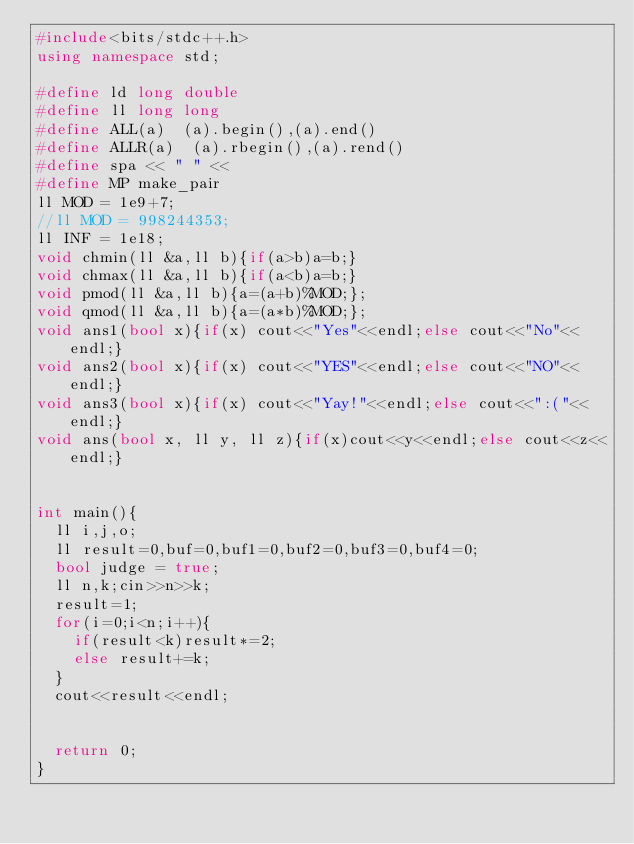<code> <loc_0><loc_0><loc_500><loc_500><_C++_>#include<bits/stdc++.h>
using namespace std;

#define ld long double
#define ll long long
#define ALL(a)  (a).begin(),(a).end()
#define ALLR(a)  (a).rbegin(),(a).rend()
#define spa << " " <<
#define MP make_pair
ll MOD = 1e9+7;
//ll MOD = 998244353;
ll INF = 1e18;
void chmin(ll &a,ll b){if(a>b)a=b;}
void chmax(ll &a,ll b){if(a<b)a=b;}
void pmod(ll &a,ll b){a=(a+b)%MOD;};
void qmod(ll &a,ll b){a=(a*b)%MOD;};
void ans1(bool x){if(x) cout<<"Yes"<<endl;else cout<<"No"<<endl;}
void ans2(bool x){if(x) cout<<"YES"<<endl;else cout<<"NO"<<endl;}
void ans3(bool x){if(x) cout<<"Yay!"<<endl;else cout<<":("<<endl;}
void ans(bool x, ll y, ll z){if(x)cout<<y<<endl;else cout<<z<<endl;}   


int main(){
  ll i,j,o;
  ll result=0,buf=0,buf1=0,buf2=0,buf3=0,buf4=0;
  bool judge = true;
  ll n,k;cin>>n>>k;
  result=1;
  for(i=0;i<n;i++){
    if(result<k)result*=2;
    else result+=k;
  }
  cout<<result<<endl;


  return 0;
}</code> 